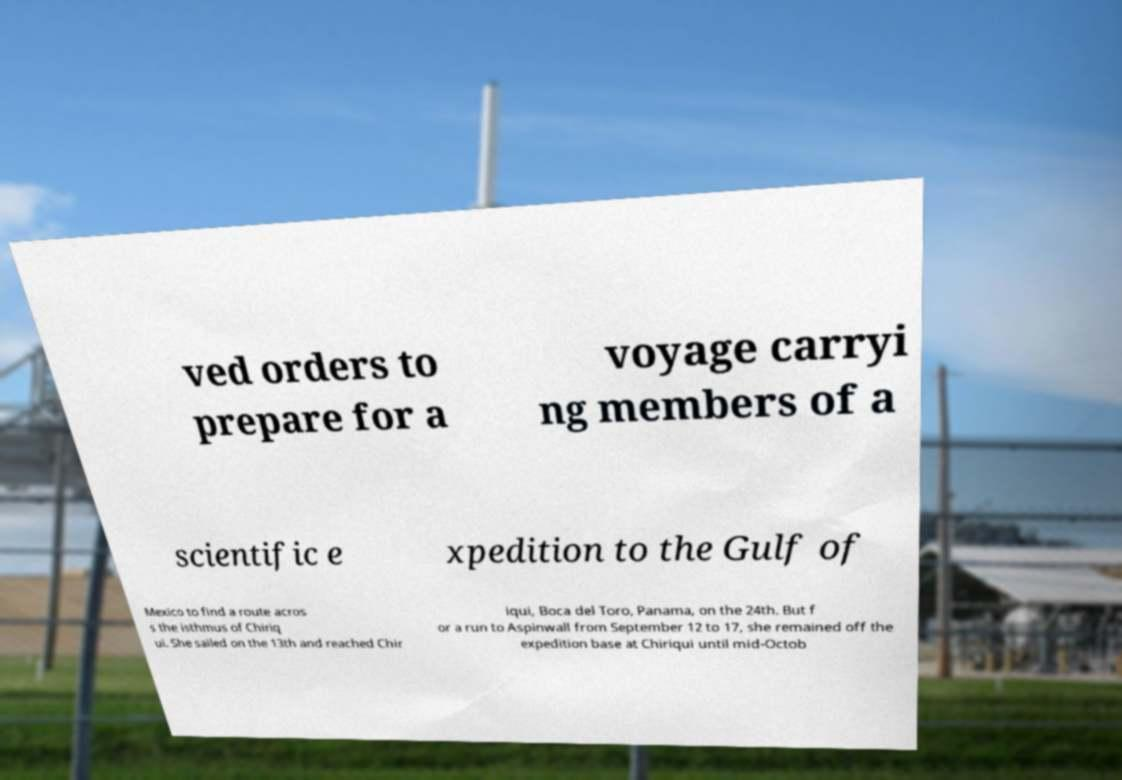I need the written content from this picture converted into text. Can you do that? ved orders to prepare for a voyage carryi ng members of a scientific e xpedition to the Gulf of Mexico to find a route acros s the isthmus of Chiriq ui. She sailed on the 13th and reached Chir iqui, Boca del Toro, Panama, on the 24th. But f or a run to Aspinwall from September 12 to 17, she remained off the expedition base at Chiriqui until mid-Octob 